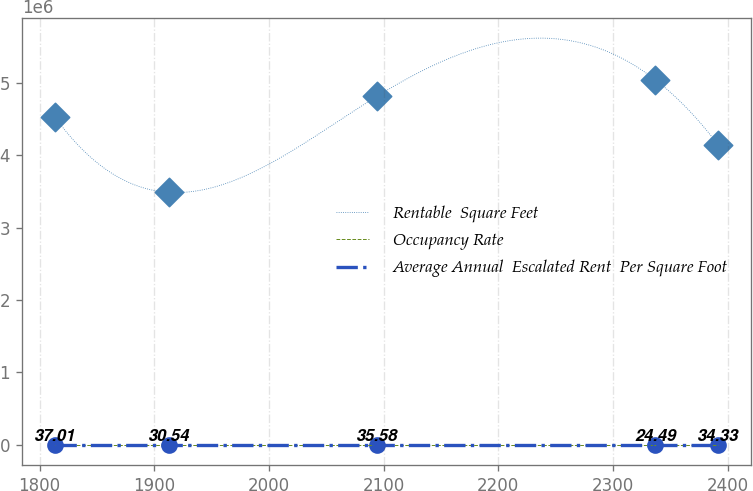Convert chart. <chart><loc_0><loc_0><loc_500><loc_500><line_chart><ecel><fcel>Rentable  Square Feet<fcel>Occupancy Rate<fcel>Average Annual  Escalated Rent  Per Square Foot<nl><fcel>1813.33<fcel>4.52713e+06<fcel>89.36<fcel>37.01<nl><fcel>1912.81<fcel>3.48718e+06<fcel>78.47<fcel>30.54<nl><fcel>2094.2<fcel>4.81477e+06<fcel>93.3<fcel>35.58<nl><fcel>2336.78<fcel>5.04374e+06<fcel>95.11<fcel>24.49<nl><fcel>2391.58<fcel>4.14513e+06<fcel>75.69<fcel>34.33<nl></chart> 